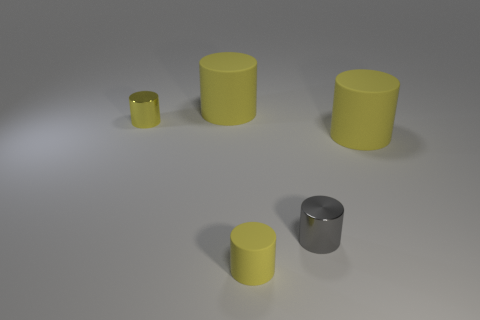How many yellow cylinders must be subtracted to get 1 yellow cylinders? 3 Subtract all purple balls. How many yellow cylinders are left? 4 Subtract 3 cylinders. How many cylinders are left? 2 Subtract all tiny gray cylinders. How many cylinders are left? 4 Subtract all gray cylinders. How many cylinders are left? 4 Add 4 gray metal objects. How many objects exist? 9 Subtract all green cylinders. Subtract all brown blocks. How many cylinders are left? 5 Subtract 0 gray cubes. How many objects are left? 5 Subtract all cyan rubber cubes. Subtract all tiny yellow things. How many objects are left? 3 Add 5 small yellow rubber objects. How many small yellow rubber objects are left? 6 